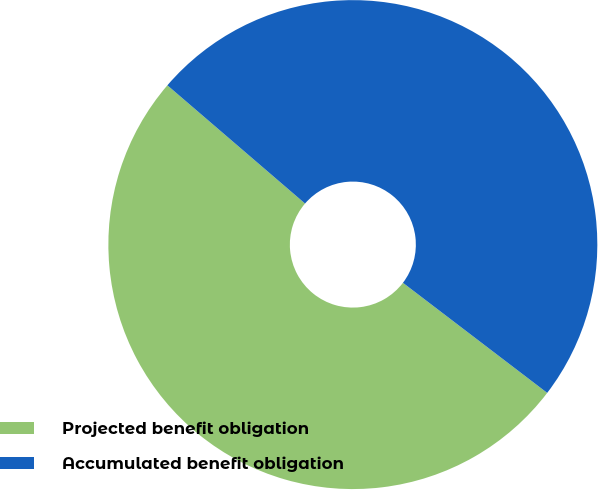Convert chart to OTSL. <chart><loc_0><loc_0><loc_500><loc_500><pie_chart><fcel>Projected benefit obligation<fcel>Accumulated benefit obligation<nl><fcel>50.92%<fcel>49.08%<nl></chart> 